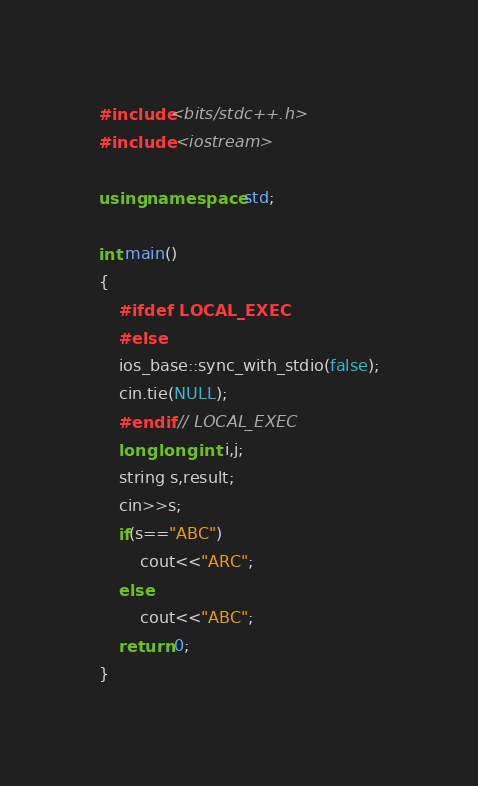Convert code to text. <code><loc_0><loc_0><loc_500><loc_500><_C++_>#include<bits/stdc++.h>
#include <iostream>

using namespace std;

int main()
{
    #ifdef LOCAL_EXEC
    #else
    ios_base::sync_with_stdio(false);
    cin.tie(NULL);
    #endif // LOCAL_EXEC
    long long int i,j;
    string s,result;
    cin>>s;
    if(s=="ABC")
        cout<<"ARC";
    else
        cout<<"ABC";
    return 0;
}
</code> 